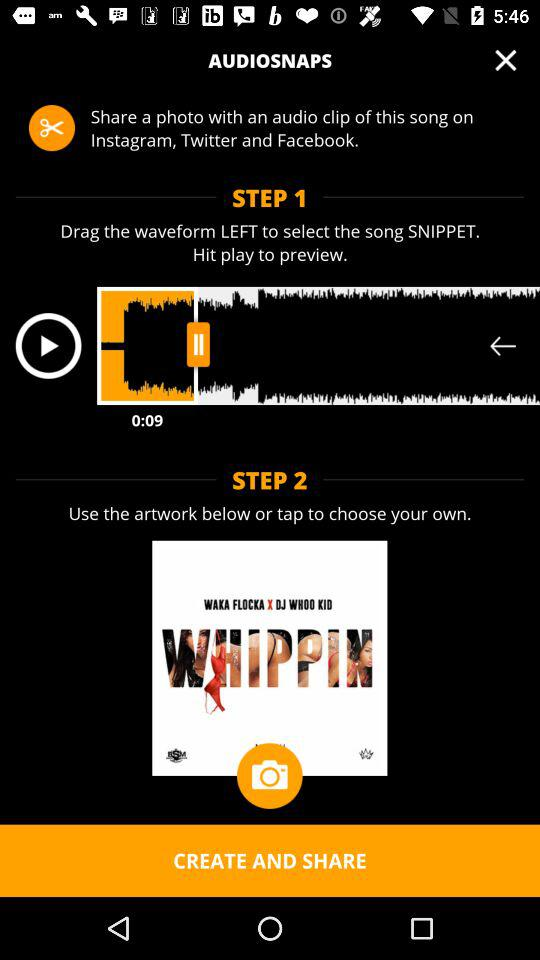What is the song name? The song name is "WAKA FLOCKA X DJ WHOO KID". 